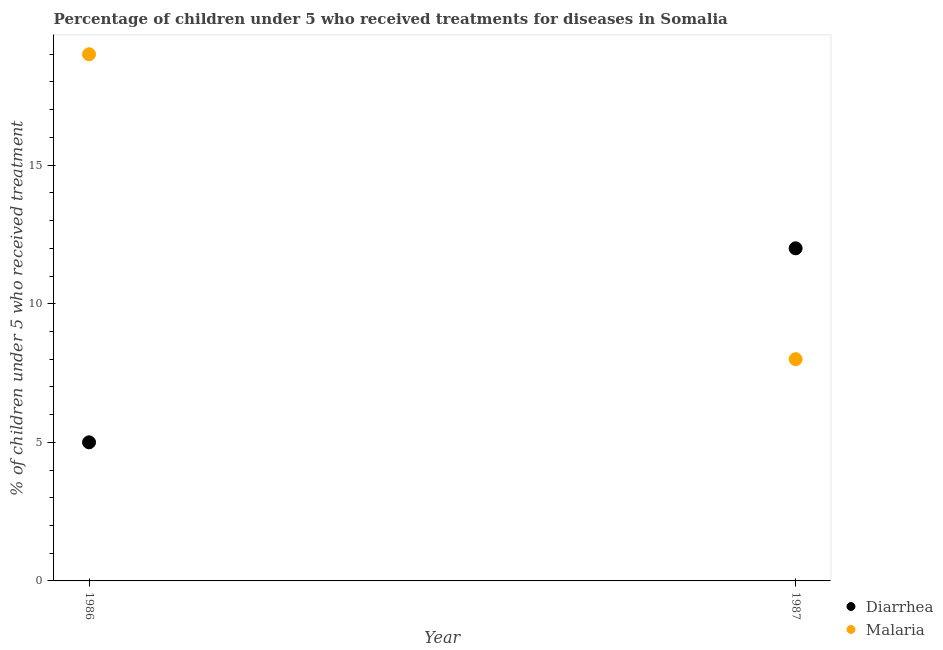What is the percentage of children who received treatment for diarrhoea in 1987?
Keep it short and to the point. 12. Across all years, what is the maximum percentage of children who received treatment for malaria?
Keep it short and to the point. 19. Across all years, what is the minimum percentage of children who received treatment for malaria?
Make the answer very short. 8. In which year was the percentage of children who received treatment for diarrhoea maximum?
Your answer should be compact. 1987. What is the total percentage of children who received treatment for malaria in the graph?
Ensure brevity in your answer.  27. What is the difference between the percentage of children who received treatment for diarrhoea in 1986 and that in 1987?
Give a very brief answer. -7. What is the difference between the percentage of children who received treatment for diarrhoea in 1987 and the percentage of children who received treatment for malaria in 1986?
Offer a terse response. -7. What is the average percentage of children who received treatment for malaria per year?
Make the answer very short. 13.5. In the year 1986, what is the difference between the percentage of children who received treatment for malaria and percentage of children who received treatment for diarrhoea?
Your response must be concise. 14. In how many years, is the percentage of children who received treatment for malaria greater than 18 %?
Your response must be concise. 1. What is the ratio of the percentage of children who received treatment for diarrhoea in 1986 to that in 1987?
Your answer should be very brief. 0.42. Is the percentage of children who received treatment for malaria in 1986 less than that in 1987?
Provide a short and direct response. No. In how many years, is the percentage of children who received treatment for diarrhoea greater than the average percentage of children who received treatment for diarrhoea taken over all years?
Your response must be concise. 1. How many years are there in the graph?
Your response must be concise. 2. Where does the legend appear in the graph?
Your answer should be very brief. Bottom right. How many legend labels are there?
Make the answer very short. 2. How are the legend labels stacked?
Offer a terse response. Vertical. What is the title of the graph?
Your response must be concise. Percentage of children under 5 who received treatments for diseases in Somalia. What is the label or title of the X-axis?
Offer a very short reply. Year. What is the label or title of the Y-axis?
Provide a short and direct response. % of children under 5 who received treatment. What is the % of children under 5 who received treatment of Malaria in 1986?
Make the answer very short. 19. What is the % of children under 5 who received treatment of Diarrhea in 1987?
Your response must be concise. 12. What is the % of children under 5 who received treatment in Malaria in 1987?
Provide a short and direct response. 8. Across all years, what is the maximum % of children under 5 who received treatment in Diarrhea?
Your response must be concise. 12. Across all years, what is the minimum % of children under 5 who received treatment of Diarrhea?
Provide a short and direct response. 5. Across all years, what is the minimum % of children under 5 who received treatment of Malaria?
Offer a terse response. 8. What is the total % of children under 5 who received treatment in Malaria in the graph?
Offer a very short reply. 27. What is the difference between the % of children under 5 who received treatment in Malaria in 1986 and that in 1987?
Offer a very short reply. 11. In the year 1986, what is the difference between the % of children under 5 who received treatment of Diarrhea and % of children under 5 who received treatment of Malaria?
Provide a succinct answer. -14. In the year 1987, what is the difference between the % of children under 5 who received treatment of Diarrhea and % of children under 5 who received treatment of Malaria?
Keep it short and to the point. 4. What is the ratio of the % of children under 5 who received treatment in Diarrhea in 1986 to that in 1987?
Keep it short and to the point. 0.42. What is the ratio of the % of children under 5 who received treatment in Malaria in 1986 to that in 1987?
Your answer should be compact. 2.38. What is the difference between the highest and the lowest % of children under 5 who received treatment in Diarrhea?
Your answer should be very brief. 7. What is the difference between the highest and the lowest % of children under 5 who received treatment of Malaria?
Make the answer very short. 11. 